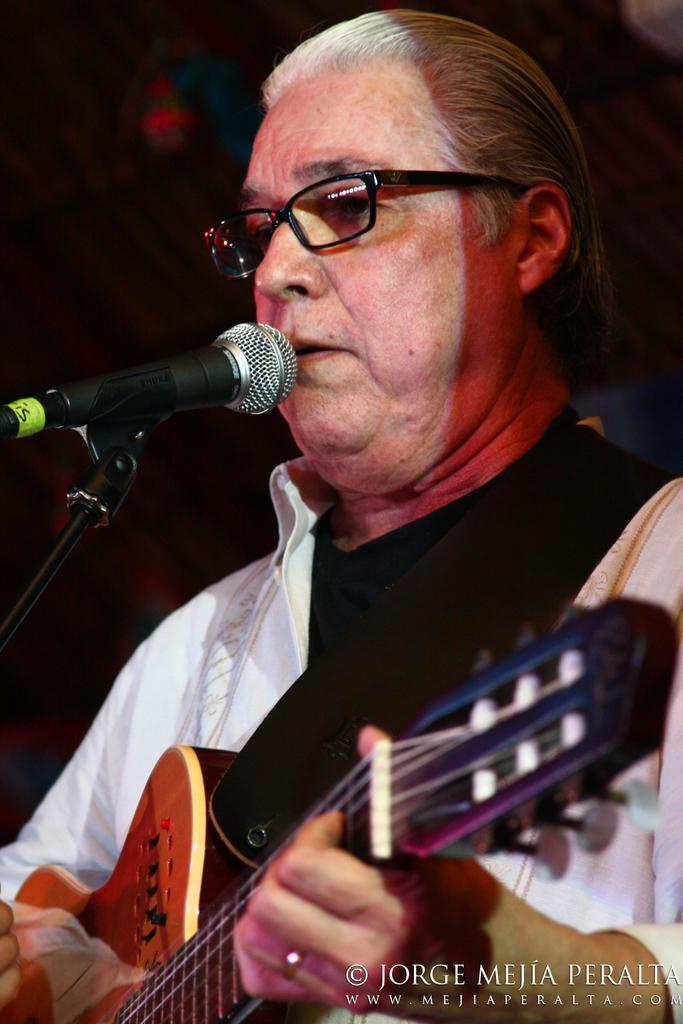How would you summarize this image in a sentence or two? In this image there is a man playing a guitar and singing a song in the microphone and there is a dark back ground. 